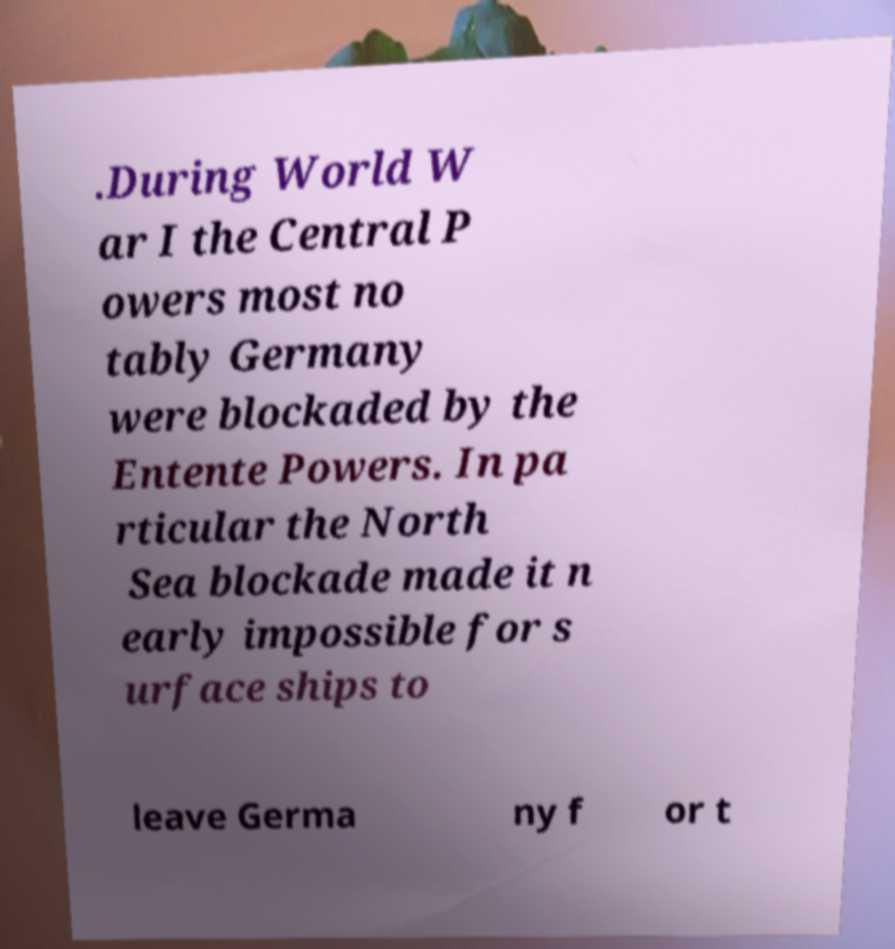Please read and relay the text visible in this image. What does it say? .During World W ar I the Central P owers most no tably Germany were blockaded by the Entente Powers. In pa rticular the North Sea blockade made it n early impossible for s urface ships to leave Germa ny f or t 